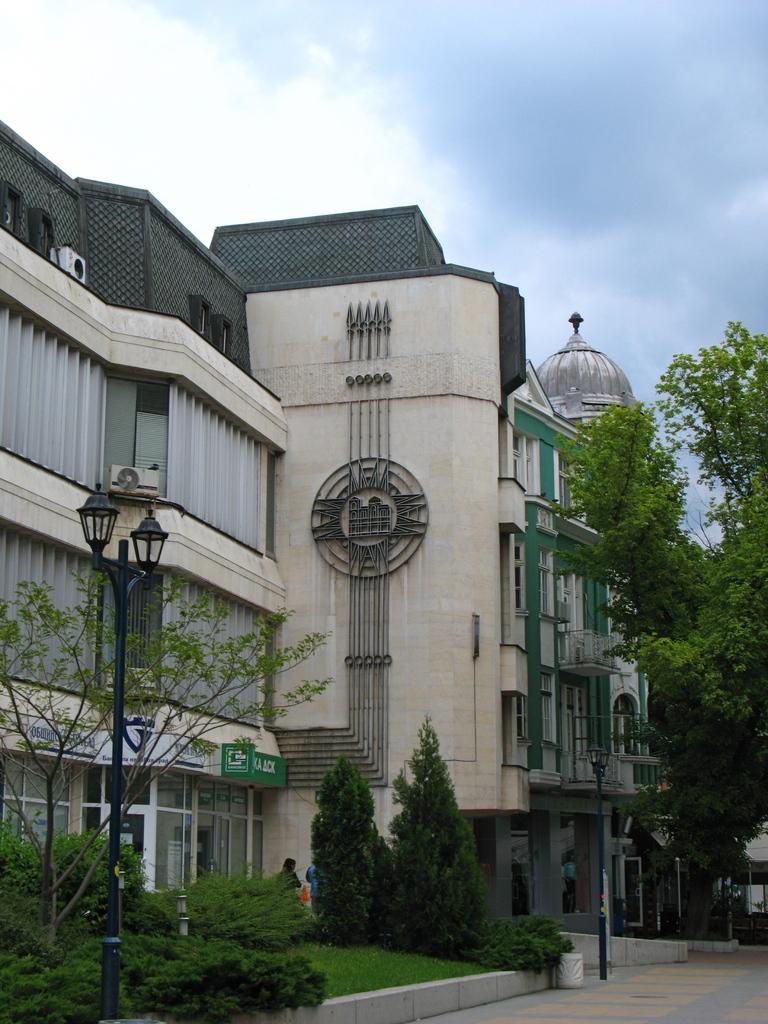How would you summarize this image in a sentence or two? In this image we can see houses, there are plants, trees, light poles, there are boards with text on them, also we can see a person and the sky. 